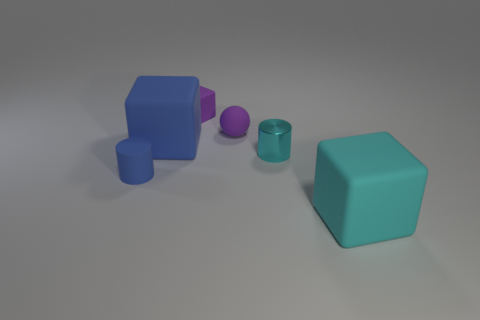Subtract all big rubber blocks. How many blocks are left? 1 Subtract all cyan blocks. How many blocks are left? 2 Subtract all yellow balls. How many blue cylinders are left? 1 Subtract 1 balls. How many balls are left? 0 Subtract all blue cylinders. Subtract all brown balls. How many cylinders are left? 1 Subtract all large blocks. Subtract all small cylinders. How many objects are left? 2 Add 5 tiny blue objects. How many tiny blue objects are left? 6 Add 3 blocks. How many blocks exist? 6 Add 2 blue shiny blocks. How many objects exist? 8 Subtract 0 gray cylinders. How many objects are left? 6 